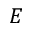Convert formula to latex. <formula><loc_0><loc_0><loc_500><loc_500>E</formula> 